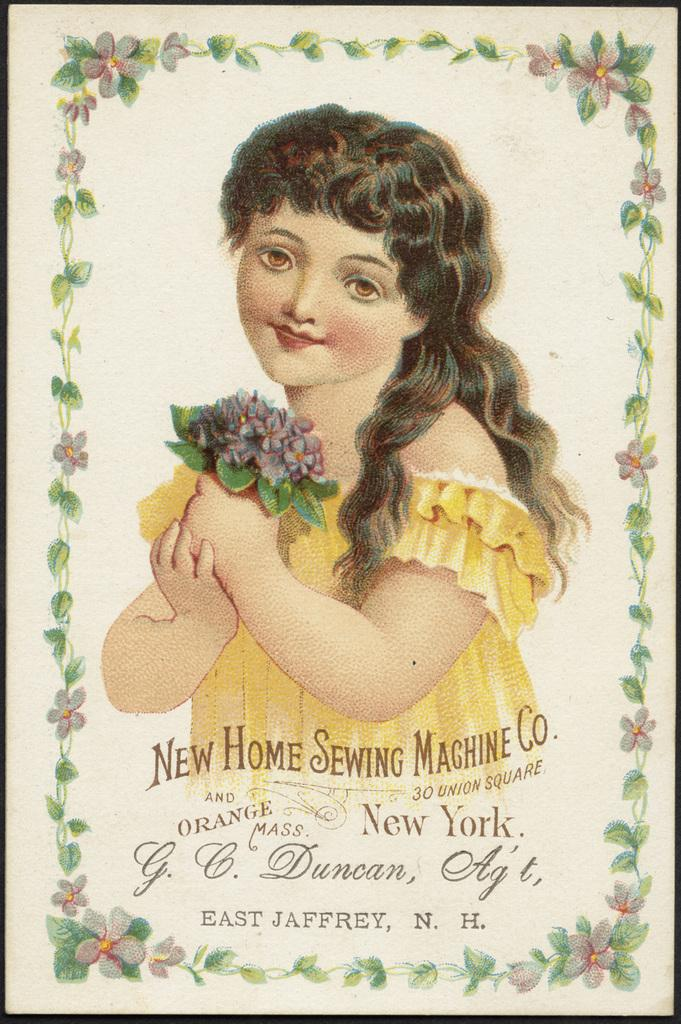What is the main subject of the paper in the image? The paper has a painting of a person. Are there any other elements on the paper besides the person? Yes, there are flowers and design on the paper. Is there any text on the paper? Yes, there is text at the bottom of the paper. How many berries are present on the paper in the image? There are no berries present on the paper in the image. 